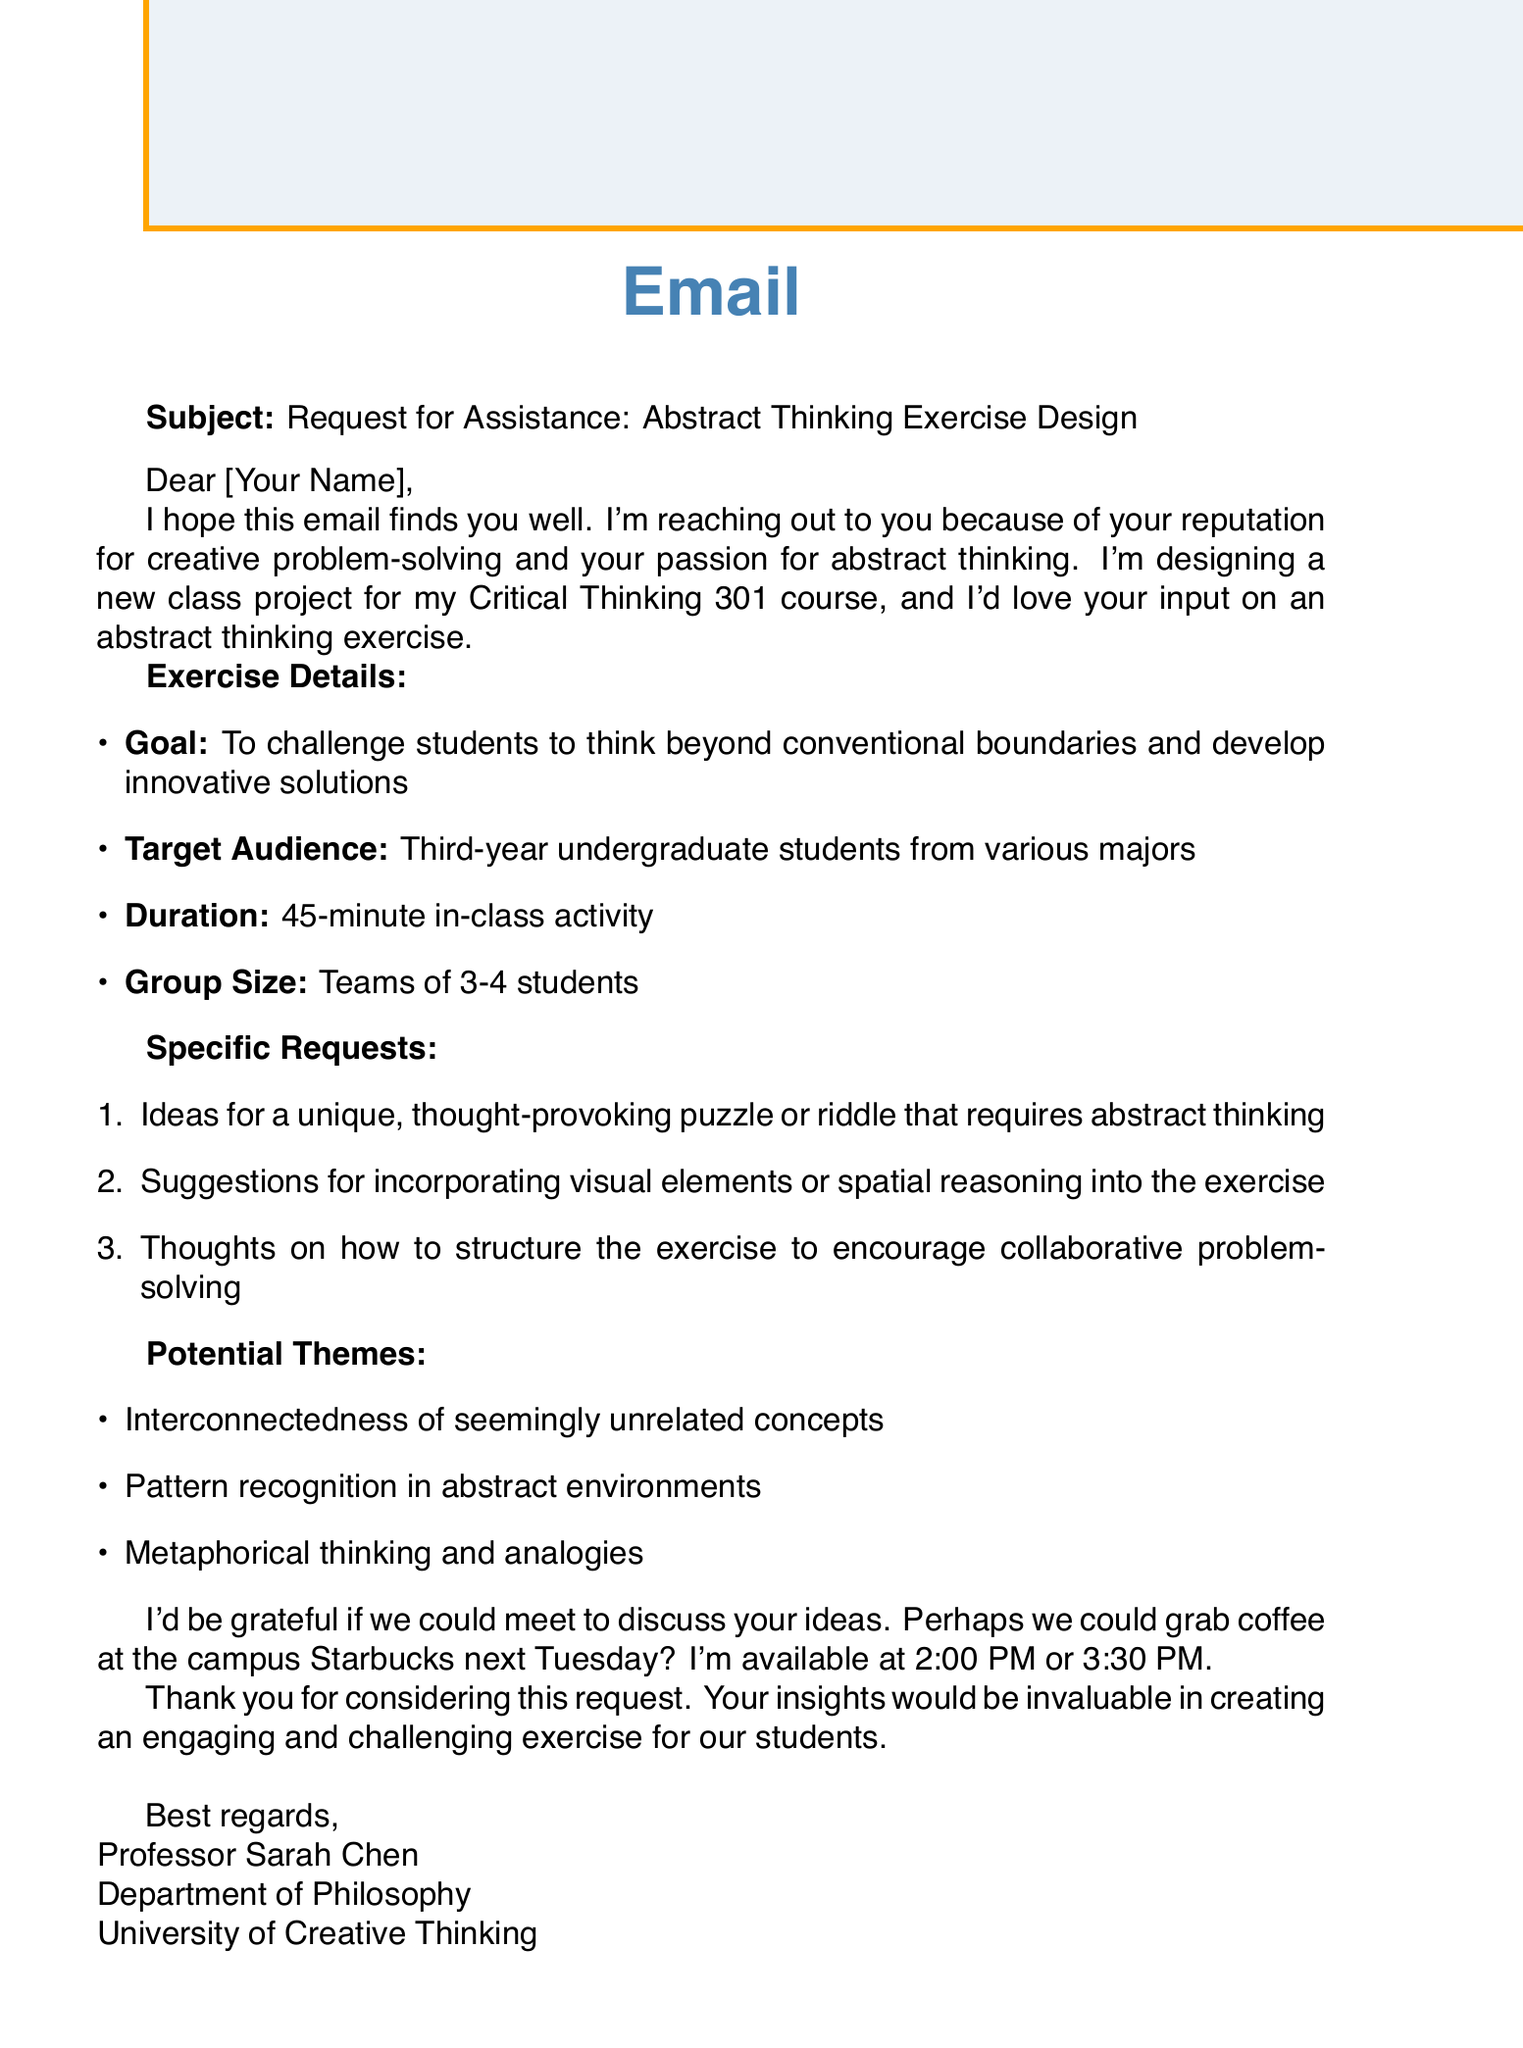What is the subject of the email? The subject is explicitly stated in the document as the reason for the communication, which is to request assistance with an exercise design.
Answer: Request for Assistance: Abstract Thinking Exercise Design Who is the sender of the email? The sender's name is included at the end of the email in the signature block.
Answer: Professor Sarah Chen What is the target audience for the exercise? The target audience is specified in the exercise details section of the email.
Answer: Third-year undergraduate students from various majors How long is the planned in-class activity? The duration of the activity is given in the exercise details section of the email.
Answer: 45-minute What is one of the specific requests made by the professor? The specific requests provide multiple ideas the professor is seeking from the recipient, with one clear example listed.
Answer: Ideas for a unique, thought-provoking puzzle or riddle that requires abstract thinking What meeting time options are provided? The professor suggests two specific times for the potential meeting mentioned in the email.
Answer: 2:00 PM or 3:30 PM What is one potential theme for the exercise? The potential themes section lists several concepts that could be used, highlighting a key idea.
Answer: Interconnectedness of seemingly unrelated concepts What does the professor express gratitude for? The closing section of the email contains an expression of thanks related to the request made.
Answer: Considering this request How many students should be in each team? The group size requirement for the activity is explicitly stated in the exercise details.
Answer: Teams of 3-4 students 